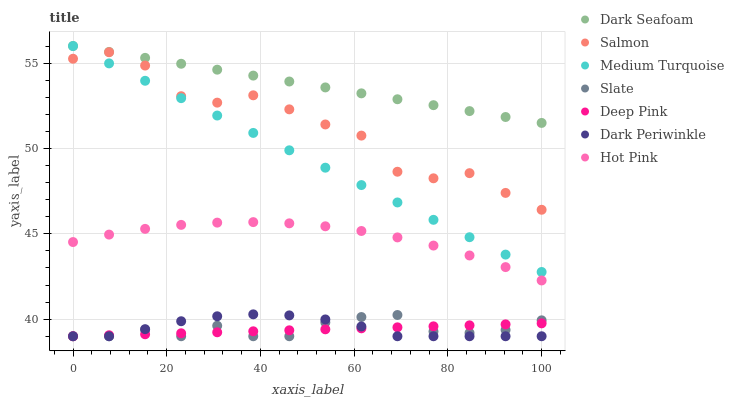Does Deep Pink have the minimum area under the curve?
Answer yes or no. Yes. Does Dark Seafoam have the maximum area under the curve?
Answer yes or no. Yes. Does Slate have the minimum area under the curve?
Answer yes or no. No. Does Slate have the maximum area under the curve?
Answer yes or no. No. Is Dark Seafoam the smoothest?
Answer yes or no. Yes. Is Salmon the roughest?
Answer yes or no. Yes. Is Slate the smoothest?
Answer yes or no. No. Is Slate the roughest?
Answer yes or no. No. Does Deep Pink have the lowest value?
Answer yes or no. Yes. Does Hot Pink have the lowest value?
Answer yes or no. No. Does Medium Turquoise have the highest value?
Answer yes or no. Yes. Does Slate have the highest value?
Answer yes or no. No. Is Deep Pink less than Salmon?
Answer yes or no. Yes. Is Hot Pink greater than Deep Pink?
Answer yes or no. Yes. Does Dark Periwinkle intersect Slate?
Answer yes or no. Yes. Is Dark Periwinkle less than Slate?
Answer yes or no. No. Is Dark Periwinkle greater than Slate?
Answer yes or no. No. Does Deep Pink intersect Salmon?
Answer yes or no. No. 